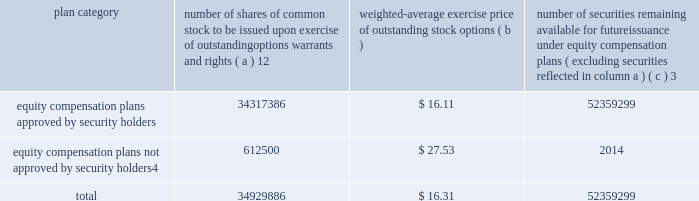Part iii item 10 .
Directors , executive officers and corporate governance the information required by this item is incorporated by reference to the 201celection of directors 201d section , the 201cdirector selection process 201d section , the 201ccode of conduct 201d section , the 201cprincipal committees of the board of directors 201d section , the 201caudit committee 201d section and the 201csection 16 ( a ) beneficial ownership reporting compliance 201d section of the proxy statement for the annual meeting of stockholders to be held on may 27 , 2010 ( the 201cproxy statement 201d ) , except for the description of our executive officers , which appears in part i of this report on form 10-k under the heading 201cexecutive officers of ipg . 201d new york stock exchange certification in 2009 , our ceo provided the annual ceo certification to the new york stock exchange , as required under section 303a.12 ( a ) of the new york stock exchange listed company manual .
Item 11 .
Executive compensation the information required by this item is incorporated by reference to the 201ccompensation of executive officers 201d section , the 201cnon-management director compensation 201d section , the 201ccompensation discussion and analysis 201d section and the 201ccompensation committee report 201d section of the proxy statement .
Item 12 .
Security ownership of certain beneficial owners and management and related stockholder matters the information required by this item is incorporated by reference to the 201coutstanding shares 201d section of the proxy statement , except for information regarding the shares of common stock to be issued or which may be issued under our equity compensation plans as of december 31 , 2009 , which is provided in the table .
Equity compensation plan information plan category number of shares of common stock to be issued upon exercise of outstanding options , warrants and rights ( a ) 12 weighted-average exercise price of outstanding stock options ( b ) number of securities remaining available for future issuance under equity compensation plans ( excluding securities reflected in column a ) ( c ) 3 equity compensation plans approved by security holders .
34317386 $ 16.11 52359299 equity compensation plans not approved by security holders 4 .
612500 $ 27.53 2014 .
1 includes a total of 6058967 performance-based share awards made under the 2004 , 2006 and 2009 performance incentive plan representing the target number of shares to be issued to employees following the completion of the 2007-2009 performance period ( the 201c2009 ltip share awards 201d ) , the 2008- 2010 performance period ( the 201c2010 ltip share awards 201d ) and the 2009-2011 performance period ( the 201c2011 ltip share awards 201d ) respectively .
The computation of the weighted-average exercise price in column ( b ) of this table does not take the 2009 ltip share awards , the 2010 ltip share awards or the 2011 ltip share awards into account .
2 includes a total of 3914804 restricted share unit and performance-based awards ( 201cshare unit awards 201d ) which may be settled in shares or cash .
The computation of the weighted-average exercise price in column ( b ) of this table does not take the share unit awards into account .
Each share unit award actually settled in cash will increase the number of shares of common stock available for issuance shown in column ( c ) .
3 includes ( i ) 37885502 shares of common stock available for issuance under the 2009 performance incentive plan , ( ii ) 13660306 shares of common stock available for issuance under the employee stock purchase plan ( 2006 ) and ( iii ) 813491 shares of common stock available for issuance under the 2009 non-management directors 2019 stock incentive plan .
4 consists of special stock option grants awarded to certain true north executives following our acquisition of true north ( the 201ctrue north options 201d ) .
The true north options have an exercise price equal to the fair market value of interpublic 2019s common stock on the date of the grant .
The terms and conditions of these stock option awards are governed by interpublic 2019s 1997 performance incentive plan .
Generally , the options become exercisable between two and five years after the date of the grant and expire ten years from the grant date. .
What percentage of remaining securities are available for issuance under the 2009 non-management directors 2019 stock incentive plan .? 
Computations: ((813491 / 52359299) * 100)
Answer: 1.55367. Part iii item 10 .
Directors , executive officers and corporate governance the information required by this item is incorporated by reference to the 201celection of directors 201d section , the 201cdirector selection process 201d section , the 201ccode of conduct 201d section , the 201cprincipal committees of the board of directors 201d section , the 201caudit committee 201d section and the 201csection 16 ( a ) beneficial ownership reporting compliance 201d section of the proxy statement for the annual meeting of stockholders to be held on may 27 , 2010 ( the 201cproxy statement 201d ) , except for the description of our executive officers , which appears in part i of this report on form 10-k under the heading 201cexecutive officers of ipg . 201d new york stock exchange certification in 2009 , our ceo provided the annual ceo certification to the new york stock exchange , as required under section 303a.12 ( a ) of the new york stock exchange listed company manual .
Item 11 .
Executive compensation the information required by this item is incorporated by reference to the 201ccompensation of executive officers 201d section , the 201cnon-management director compensation 201d section , the 201ccompensation discussion and analysis 201d section and the 201ccompensation committee report 201d section of the proxy statement .
Item 12 .
Security ownership of certain beneficial owners and management and related stockholder matters the information required by this item is incorporated by reference to the 201coutstanding shares 201d section of the proxy statement , except for information regarding the shares of common stock to be issued or which may be issued under our equity compensation plans as of december 31 , 2009 , which is provided in the table .
Equity compensation plan information plan category number of shares of common stock to be issued upon exercise of outstanding options , warrants and rights ( a ) 12 weighted-average exercise price of outstanding stock options ( b ) number of securities remaining available for future issuance under equity compensation plans ( excluding securities reflected in column a ) ( c ) 3 equity compensation plans approved by security holders .
34317386 $ 16.11 52359299 equity compensation plans not approved by security holders 4 .
612500 $ 27.53 2014 .
1 includes a total of 6058967 performance-based share awards made under the 2004 , 2006 and 2009 performance incentive plan representing the target number of shares to be issued to employees following the completion of the 2007-2009 performance period ( the 201c2009 ltip share awards 201d ) , the 2008- 2010 performance period ( the 201c2010 ltip share awards 201d ) and the 2009-2011 performance period ( the 201c2011 ltip share awards 201d ) respectively .
The computation of the weighted-average exercise price in column ( b ) of this table does not take the 2009 ltip share awards , the 2010 ltip share awards or the 2011 ltip share awards into account .
2 includes a total of 3914804 restricted share unit and performance-based awards ( 201cshare unit awards 201d ) which may be settled in shares or cash .
The computation of the weighted-average exercise price in column ( b ) of this table does not take the share unit awards into account .
Each share unit award actually settled in cash will increase the number of shares of common stock available for issuance shown in column ( c ) .
3 includes ( i ) 37885502 shares of common stock available for issuance under the 2009 performance incentive plan , ( ii ) 13660306 shares of common stock available for issuance under the employee stock purchase plan ( 2006 ) and ( iii ) 813491 shares of common stock available for issuance under the 2009 non-management directors 2019 stock incentive plan .
4 consists of special stock option grants awarded to certain true north executives following our acquisition of true north ( the 201ctrue north options 201d ) .
The true north options have an exercise price equal to the fair market value of interpublic 2019s common stock on the date of the grant .
The terms and conditions of these stock option awards are governed by interpublic 2019s 1997 performance incentive plan .
Generally , the options become exercisable between two and five years after the date of the grant and expire ten years from the grant date. .
Of the number of shares of common stock to be issued upon exercise of outstanding options warrants and rights what was the percent approved by security holders? 
Computations: (34317386 / 34929886)
Answer: 0.98246. 